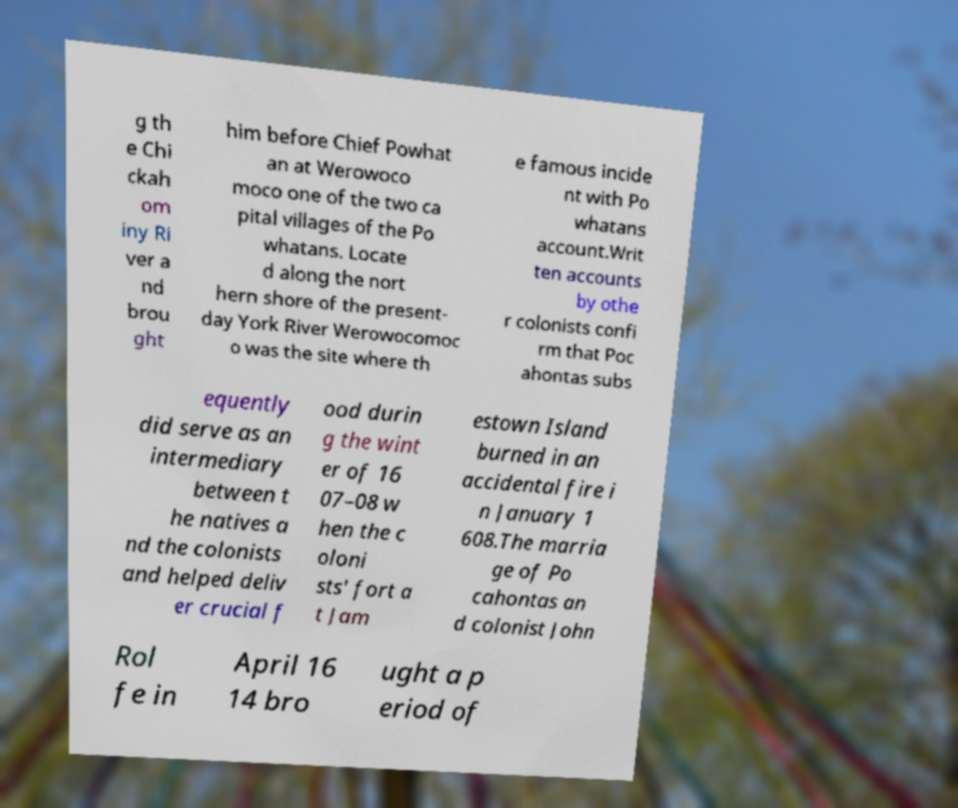Could you assist in decoding the text presented in this image and type it out clearly? g th e Chi ckah om iny Ri ver a nd brou ght him before Chief Powhat an at Werowoco moco one of the two ca pital villages of the Po whatans. Locate d along the nort hern shore of the present- day York River Werowocomoc o was the site where th e famous incide nt with Po whatans account.Writ ten accounts by othe r colonists confi rm that Poc ahontas subs equently did serve as an intermediary between t he natives a nd the colonists and helped deliv er crucial f ood durin g the wint er of 16 07–08 w hen the c oloni sts' fort a t Jam estown Island burned in an accidental fire i n January 1 608.The marria ge of Po cahontas an d colonist John Rol fe in April 16 14 bro ught a p eriod of 